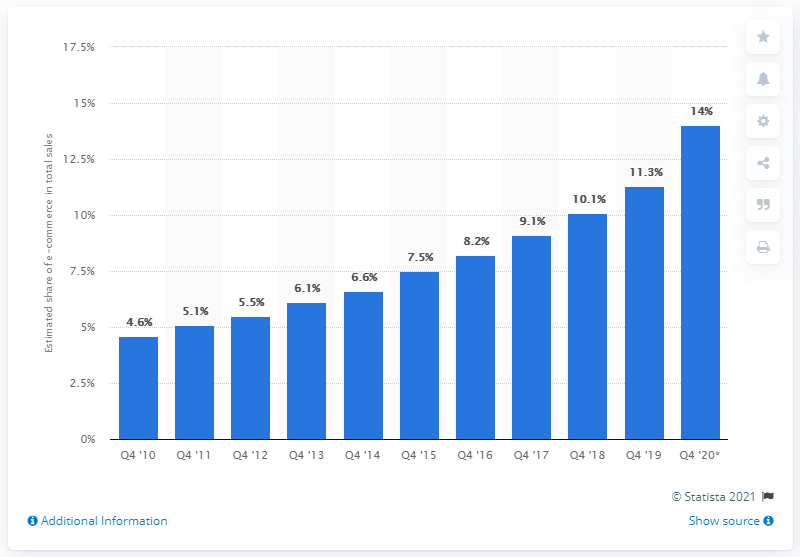Specify some key components in this picture. In 2010, e-commerce accounted for 4.6% of total retail sales in the United States. 